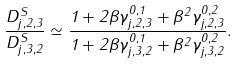<formula> <loc_0><loc_0><loc_500><loc_500>\frac { D ^ { S } _ { j , 2 , 3 } } { D ^ { S } _ { j , 3 , 2 } } \simeq \frac { 1 + 2 \beta \gamma ^ { 0 , 1 } _ { j , 2 , 3 } + \beta ^ { 2 } \gamma ^ { 0 , 2 } _ { j , 2 , 3 } } { 1 + 2 \beta \gamma ^ { 0 , 1 } _ { j , 3 , 2 } + \beta ^ { 2 } \gamma ^ { 0 , 2 } _ { j , 3 , 2 } } .</formula> 